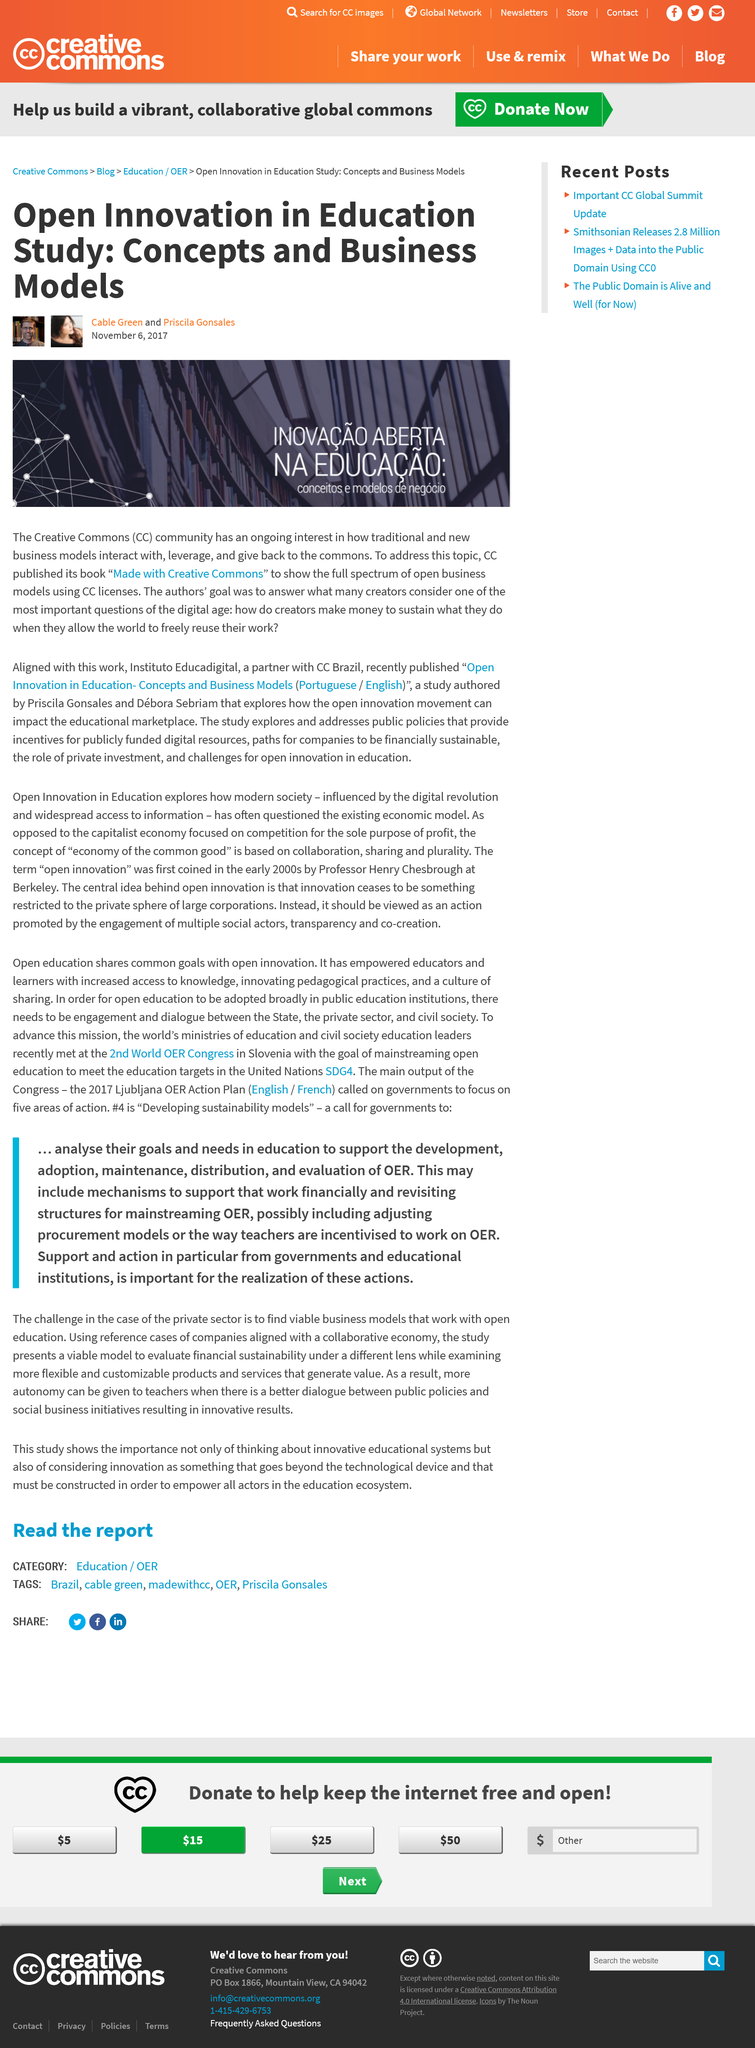Indicate a few pertinent items in this graphic. The book that was published by CC is titled [insert title here]. This book was created using Creative Commons. Creative Commons is a nonprofit organization that offers a range of free licenses to creators and copyright holders to allow them to share their work while retaining some control over how it is used. These licenses, which are identified by the acronym CC, provide a flexible and standardized way for creators to give permission to others to use their work under certain conditions. The purpose of Creative Commons is to enable and support the creative reuse of digital content, allowing creators to share their work while still protecting their rights and encouraging innovation and creativity. The female author of this article is Priscila Gonsales. 